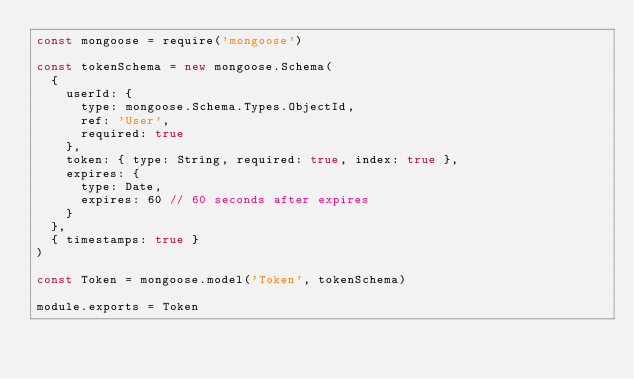<code> <loc_0><loc_0><loc_500><loc_500><_JavaScript_>const mongoose = require('mongoose')

const tokenSchema = new mongoose.Schema(
  {
    userId: {
      type: mongoose.Schema.Types.ObjectId,
      ref: 'User',
      required: true
    },
    token: { type: String, required: true, index: true },
    expires: {
      type: Date,
      expires: 60 // 60 seconds after expires
    }
  },
  { timestamps: true }
)

const Token = mongoose.model('Token', tokenSchema)

module.exports = Token
</code> 